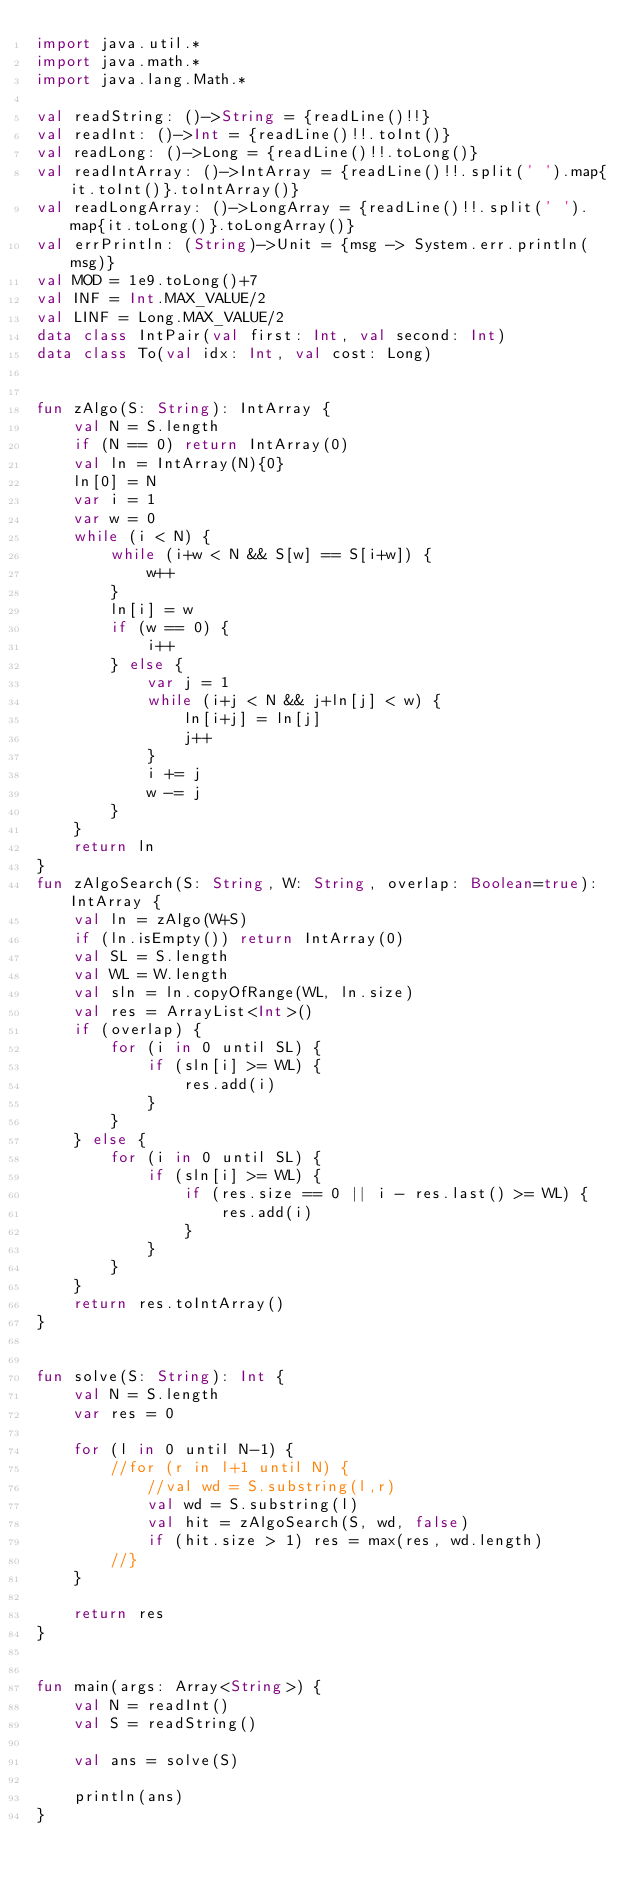Convert code to text. <code><loc_0><loc_0><loc_500><loc_500><_Kotlin_>import java.util.*
import java.math.*
import java.lang.Math.*

val readString: ()->String = {readLine()!!}
val readInt: ()->Int = {readLine()!!.toInt()}
val readLong: ()->Long = {readLine()!!.toLong()}
val readIntArray: ()->IntArray = {readLine()!!.split(' ').map{it.toInt()}.toIntArray()}
val readLongArray: ()->LongArray = {readLine()!!.split(' ').map{it.toLong()}.toLongArray()}
val errPrintln: (String)->Unit = {msg -> System.err.println(msg)}
val MOD = 1e9.toLong()+7
val INF = Int.MAX_VALUE/2
val LINF = Long.MAX_VALUE/2
data class IntPair(val first: Int, val second: Int)
data class To(val idx: Int, val cost: Long)


fun zAlgo(S: String): IntArray {
    val N = S.length
    if (N == 0) return IntArray(0)
    val ln = IntArray(N){0}
    ln[0] = N
    var i = 1
    var w = 0
    while (i < N) {
        while (i+w < N && S[w] == S[i+w]) {
            w++
        }
        ln[i] = w
        if (w == 0) {
            i++
        } else {
            var j = 1
            while (i+j < N && j+ln[j] < w) {
                ln[i+j] = ln[j]
                j++
            }
            i += j
            w -= j
        }
    }
    return ln
}
fun zAlgoSearch(S: String, W: String, overlap: Boolean=true): IntArray {
    val ln = zAlgo(W+S)
    if (ln.isEmpty()) return IntArray(0)
    val SL = S.length
    val WL = W.length
    val sln = ln.copyOfRange(WL, ln.size)
    val res = ArrayList<Int>()
    if (overlap) {
        for (i in 0 until SL) {
            if (sln[i] >= WL) {
                res.add(i)
            }
        }
    } else {
        for (i in 0 until SL) {
            if (sln[i] >= WL) {
                if (res.size == 0 || i - res.last() >= WL) {
                    res.add(i)
                }
            }
        }
    }
    return res.toIntArray()
}


fun solve(S: String): Int {
    val N = S.length
    var res = 0

    for (l in 0 until N-1) {
        //for (r in l+1 until N) {
            //val wd = S.substring(l,r)
            val wd = S.substring(l)
            val hit = zAlgoSearch(S, wd, false)
            if (hit.size > 1) res = max(res, wd.length)
        //}
    }

    return res
}


fun main(args: Array<String>) {
    val N = readInt()
    val S = readString()

    val ans = solve(S)

    println(ans)
}
</code> 